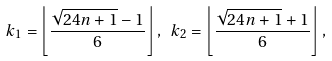Convert formula to latex. <formula><loc_0><loc_0><loc_500><loc_500>k _ { 1 } = \left \lfloor \frac { \sqrt { 2 4 n + 1 } - 1 } { 6 } \right \rfloor , \ k _ { 2 } = \left \lfloor \frac { \sqrt { 2 4 n + 1 } + 1 } { 6 } \right \rfloor ,</formula> 